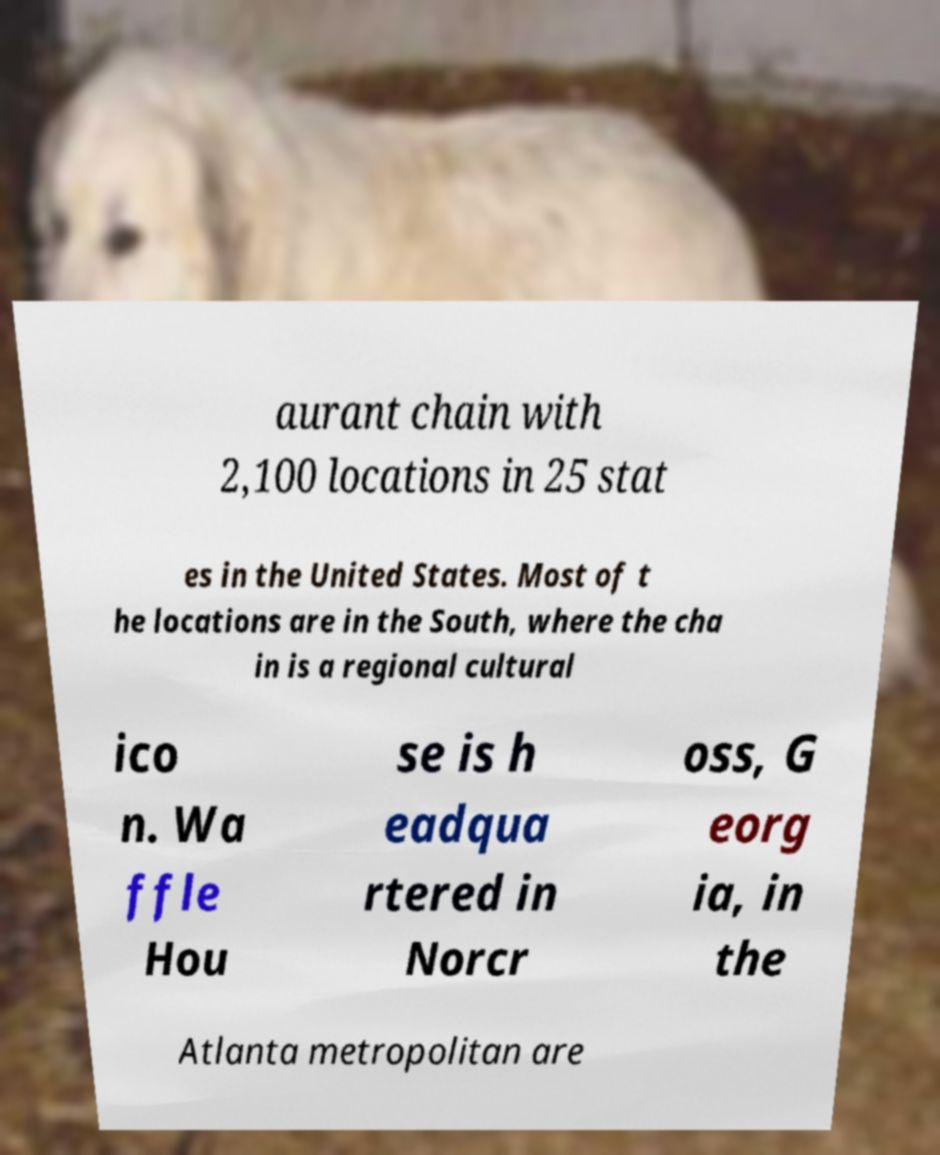Can you accurately transcribe the text from the provided image for me? aurant chain with 2,100 locations in 25 stat es in the United States. Most of t he locations are in the South, where the cha in is a regional cultural ico n. Wa ffle Hou se is h eadqua rtered in Norcr oss, G eorg ia, in the Atlanta metropolitan are 